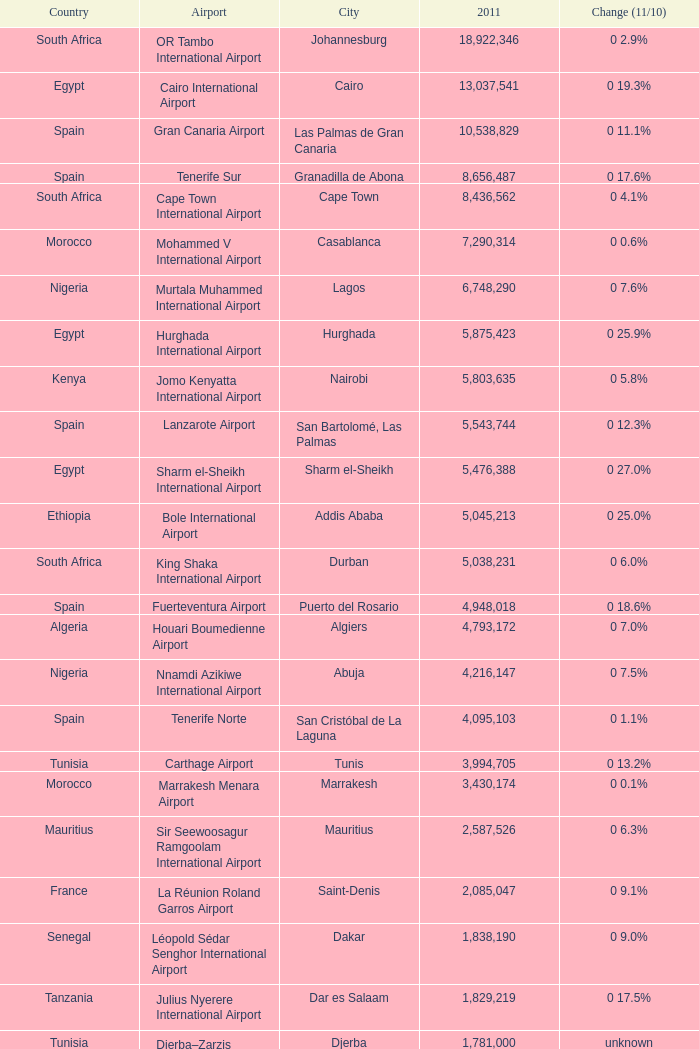Which 2011 has an Airport of bole international airport? 5045213.0. 